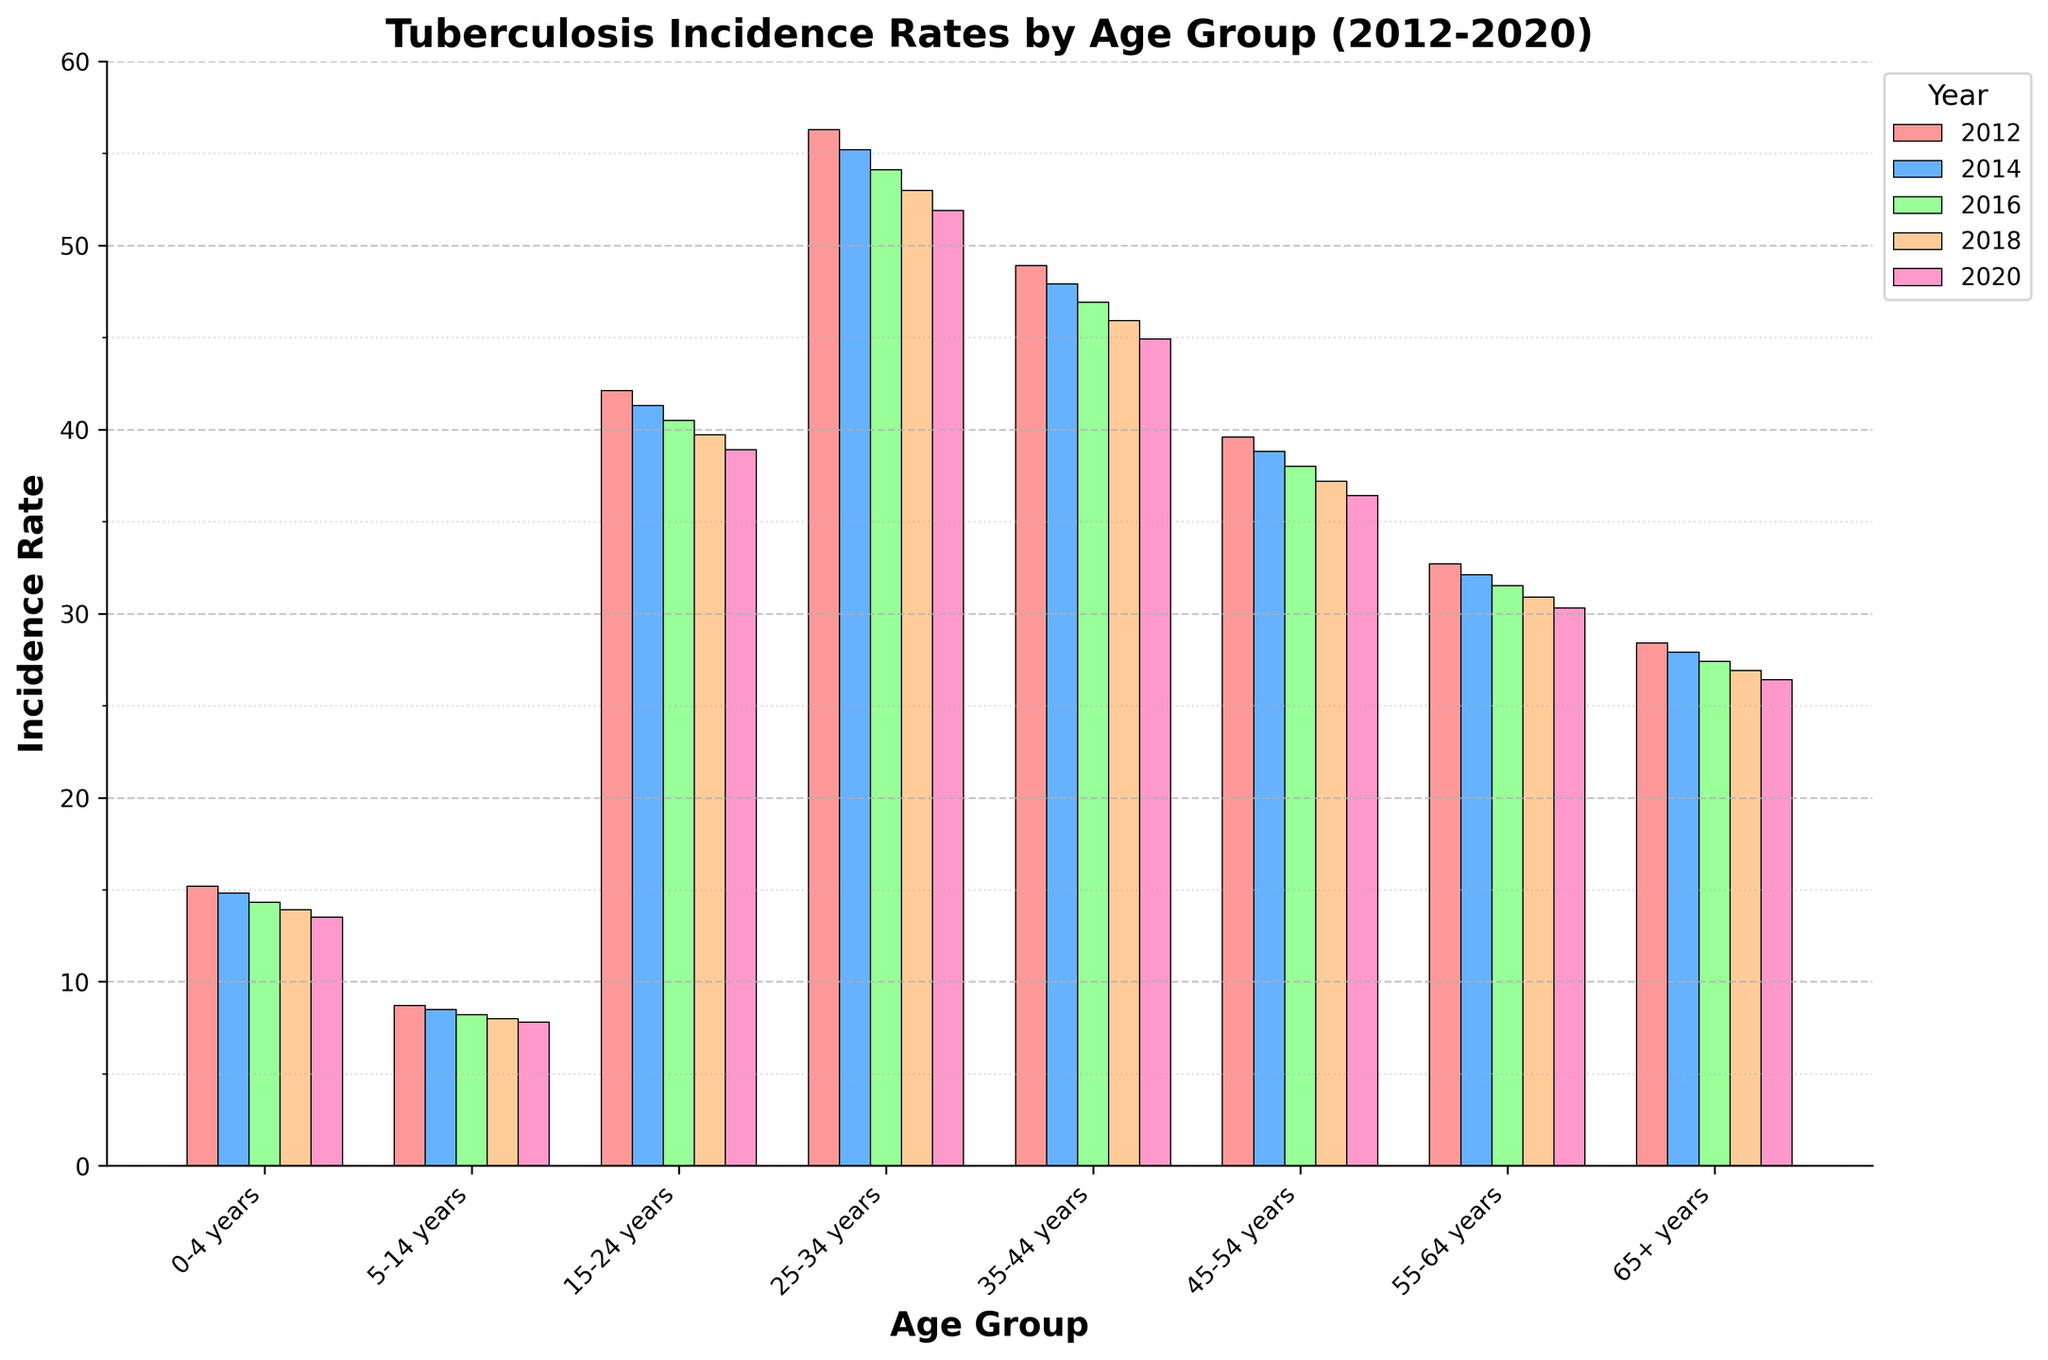what is the incidence rate for the 0-4 years age group in 2020? To find the incidence rate for the 0-4 years age group in 2020, look at the bar corresponding to the 0-4 years category and the color representing 2020. The height of the bar indicates the incidence rate.
Answer: 13.5 Which age group saw the biggest decrease in incidence rates from 2012 to 2020? Calculate the difference between the incidence rates in 2012 and 2020 for each age group, then identify the group with the largest difference. For instance, for the 25-34 years age group, the difference is 56.3 - 51.9 = 4.4, while for the 15-24 years age group, the difference is 42.1 - 38.9 = 3.2. Do this for all groups and compare the differences.
Answer: 25-34 years What's the average incidence rate for the 5-14 years age group across all years shown? To find the average, add the incidence rates for the 5-14 years age group across all years (8.7, 8.5, 8.2, 8.0, 7.8) and divide by the number of years. (8.7 + 8.5 + 8.2 + 8.0 + 7.8)/5 = 41.2/5
Answer: 8.24 Which year had the lowest incidence rate for the 65+ years age group? Compare the heights of the bars for the 65+ years age group color-coded by year. Identify which bar is the shortest, indicating the lowest incidence rate. Here the values are 28.4, 27.9, 27.4, 26.9, and 26.4. The lowest value is in 2020.
Answer: 2020 In 2018, which age group had the highest incidence rate? Look at the bars color-coded for the year 2018 and identify which bar is the tallest among all age groups. The group is 25-34 years with 53.0.
Answer: 25-34 years What's the total incidence rate for the 35-44 years age group over all the given years? Sum the incidence rates for the 35-44 years age group across all provided years (2012, 2014, 2016, 2018, 2020): 48.9 + 47.9 + 46.9 + 45.9 + 44.9 = 234.5.
Answer: 234.5 Which age group had the smallest decrease in incidence rate from 2012 to 2020? Calculate the difference in incidence rates between 2012 and 2020 for each group and determine the smallest difference. For example, for the 0-4 years age group: 15.2 - 13.5 = 1.7. Similarly, calculate for each group and compare the differences.
Answer: 0-4 years 